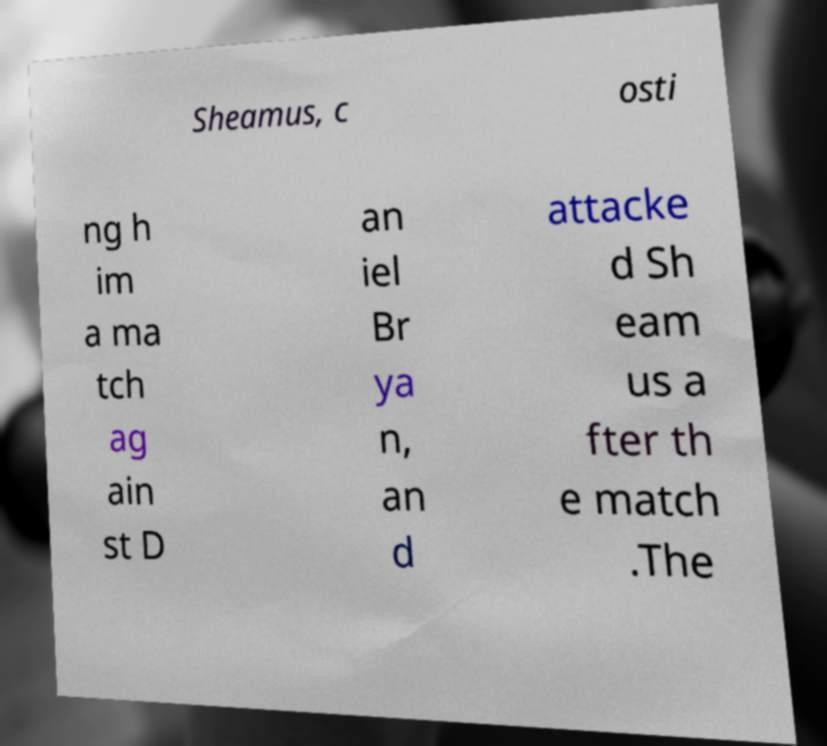Could you extract and type out the text from this image? Sheamus, c osti ng h im a ma tch ag ain st D an iel Br ya n, an d attacke d Sh eam us a fter th e match .The 